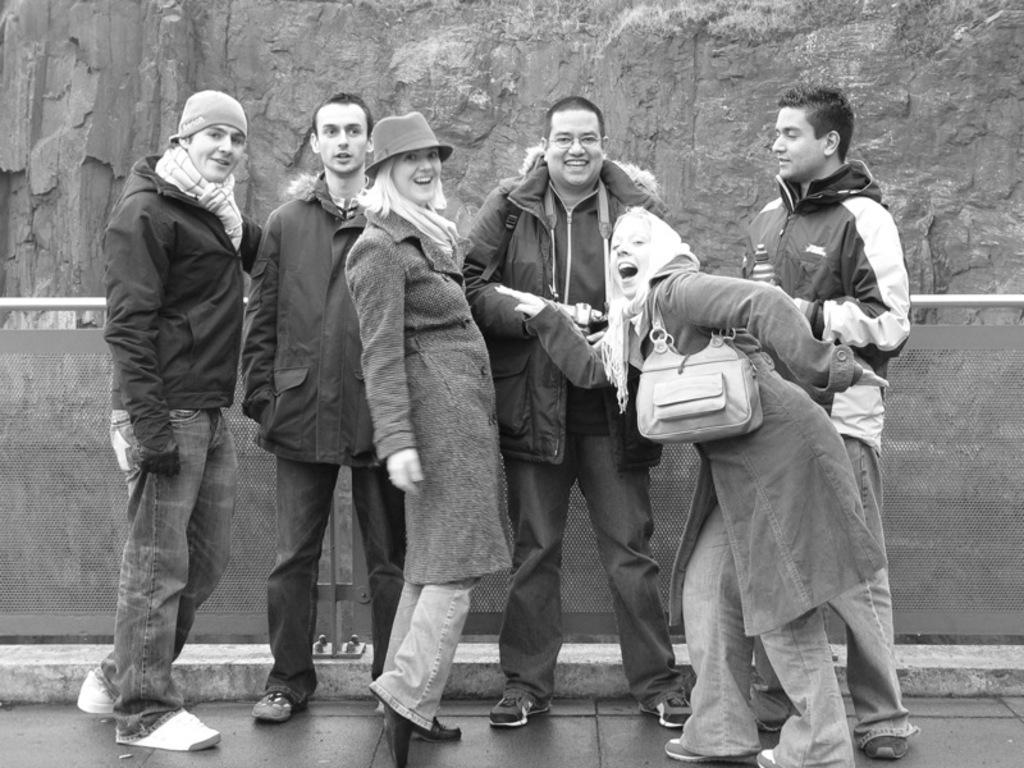How many people are in the image? There is a group of people in the image. What are the people doing in the image? The people are standing on a path and smiling. What can be seen in the background of the image? There is a wall in the background of the image. What is behind the wall in the image? There is a rock wall behind the wall. What grade is the wall in the image? The wall in the image is not a grade; it is a physical structure. 